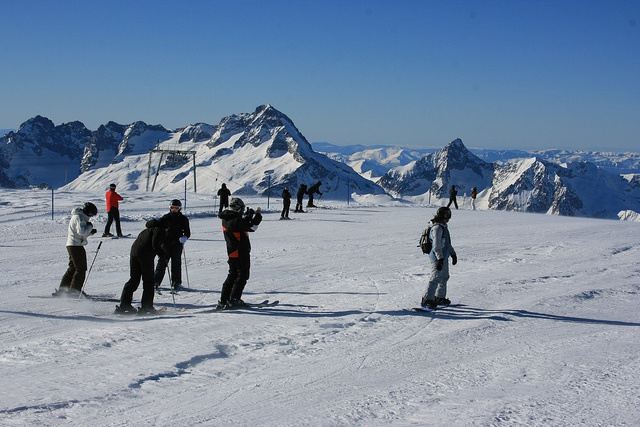Describe the objects in this image and their specific colors. I can see people in gray, black, darkgray, and darkblue tones, people in gray, black, maroon, and darkgray tones, people in gray, black, darkgray, and lightgray tones, people in gray, black, and darkgray tones, and people in gray, black, navy, and darkgray tones in this image. 